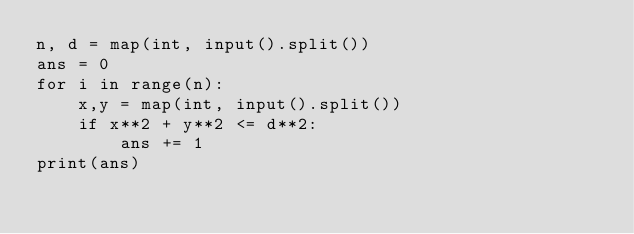<code> <loc_0><loc_0><loc_500><loc_500><_Python_>n, d = map(int, input().split())
ans = 0
for i in range(n):
    x,y = map(int, input().split())
    if x**2 + y**2 <= d**2:
        ans += 1
print(ans)</code> 